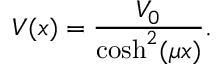<formula> <loc_0><loc_0><loc_500><loc_500>V ( x ) = \frac { V _ { 0 } } { \cosh ^ { 2 } ( \mu x ) } .</formula> 